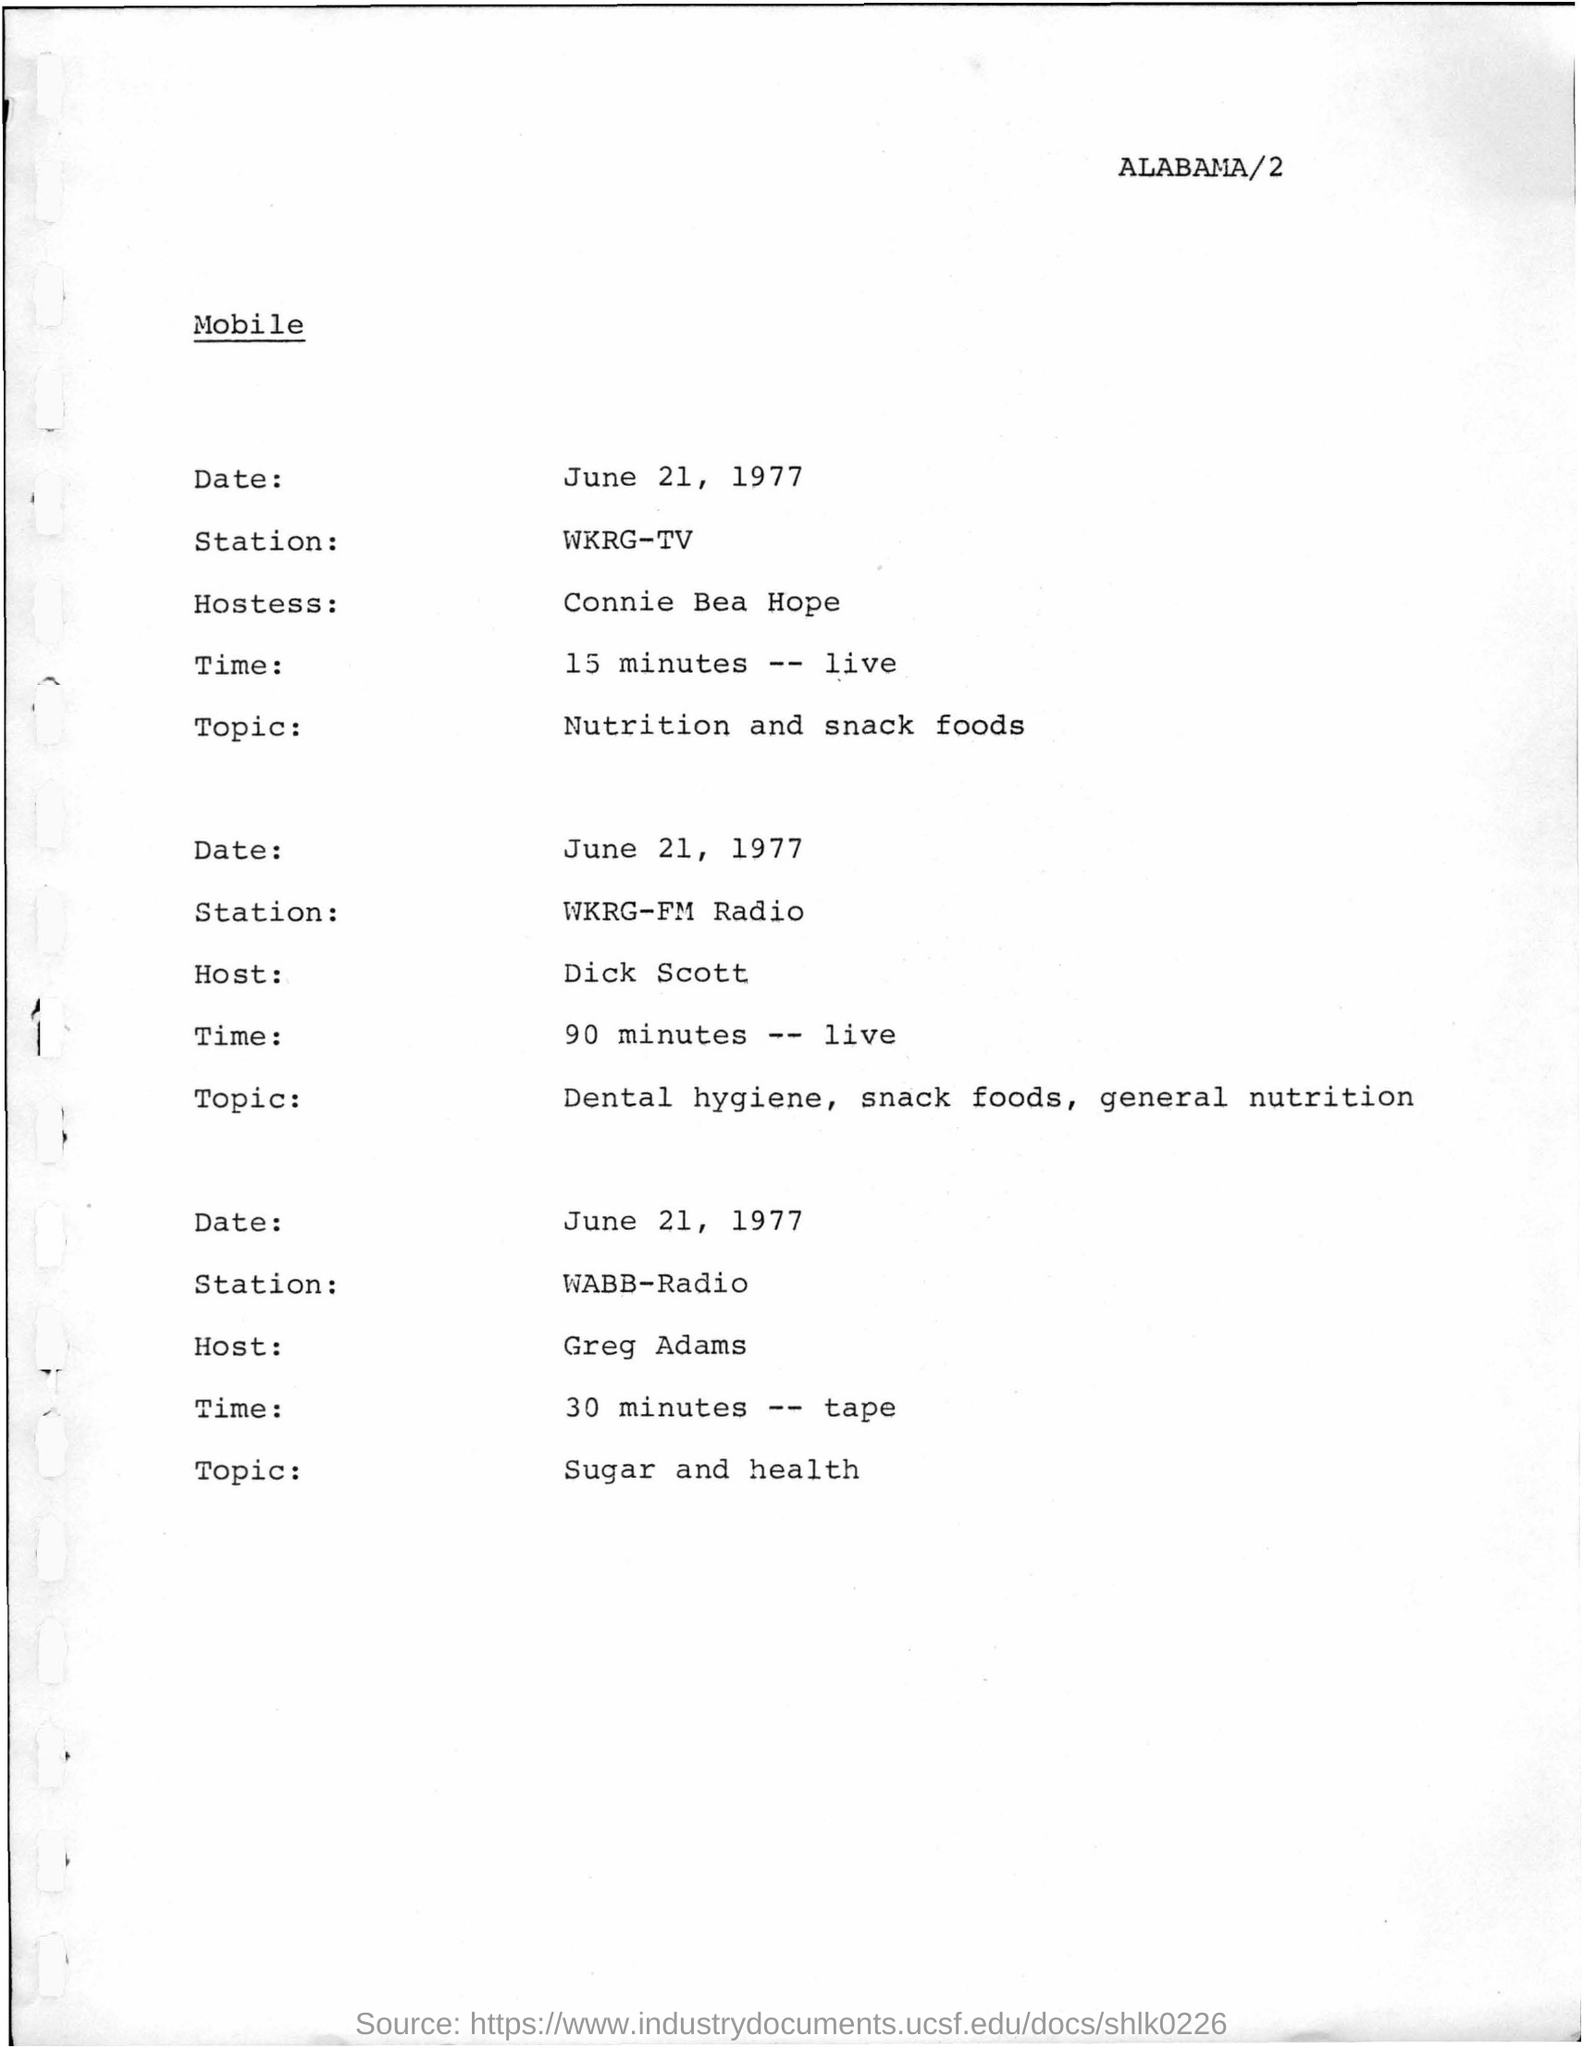Who is the Hostess for Nutrition and snack foods?
Your answer should be very brief. Connie Bea Hope. How many minutes are scheduled for the topic Dental hygiene, snack foods, general nutrition?
Offer a very short reply. 90. Which radio station is mentioned for the topic Sugar and health?
Give a very brief answer. WABB. Who is the host for the topic Sugar and health?
Provide a short and direct response. Greg Adams. 